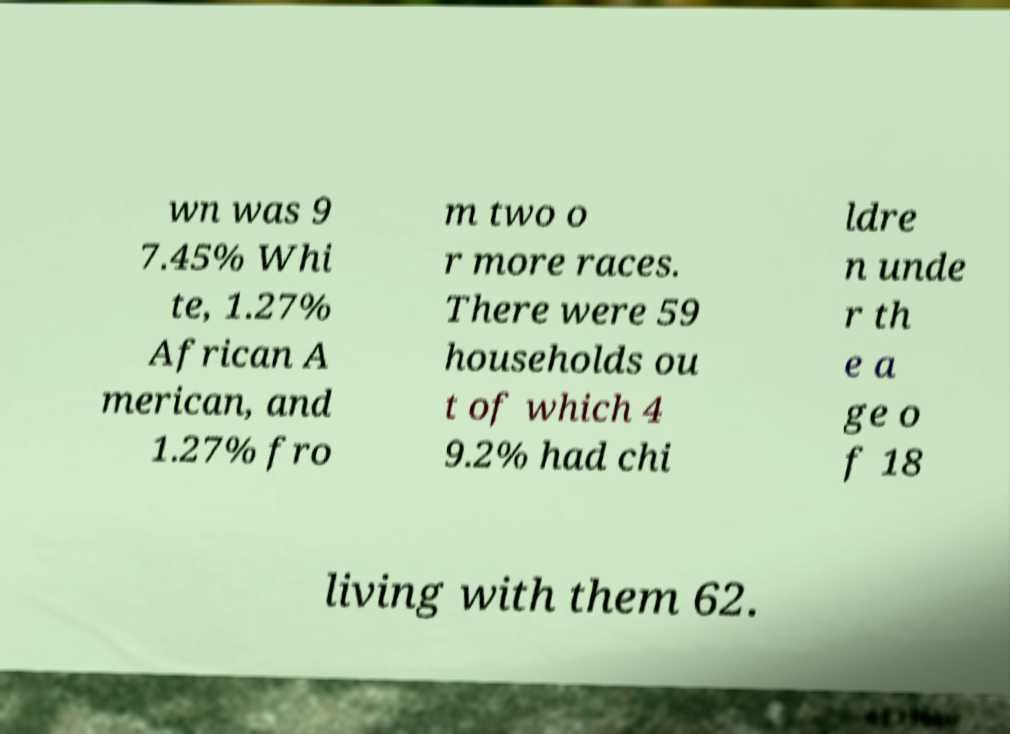Please read and relay the text visible in this image. What does it say? wn was 9 7.45% Whi te, 1.27% African A merican, and 1.27% fro m two o r more races. There were 59 households ou t of which 4 9.2% had chi ldre n unde r th e a ge o f 18 living with them 62. 